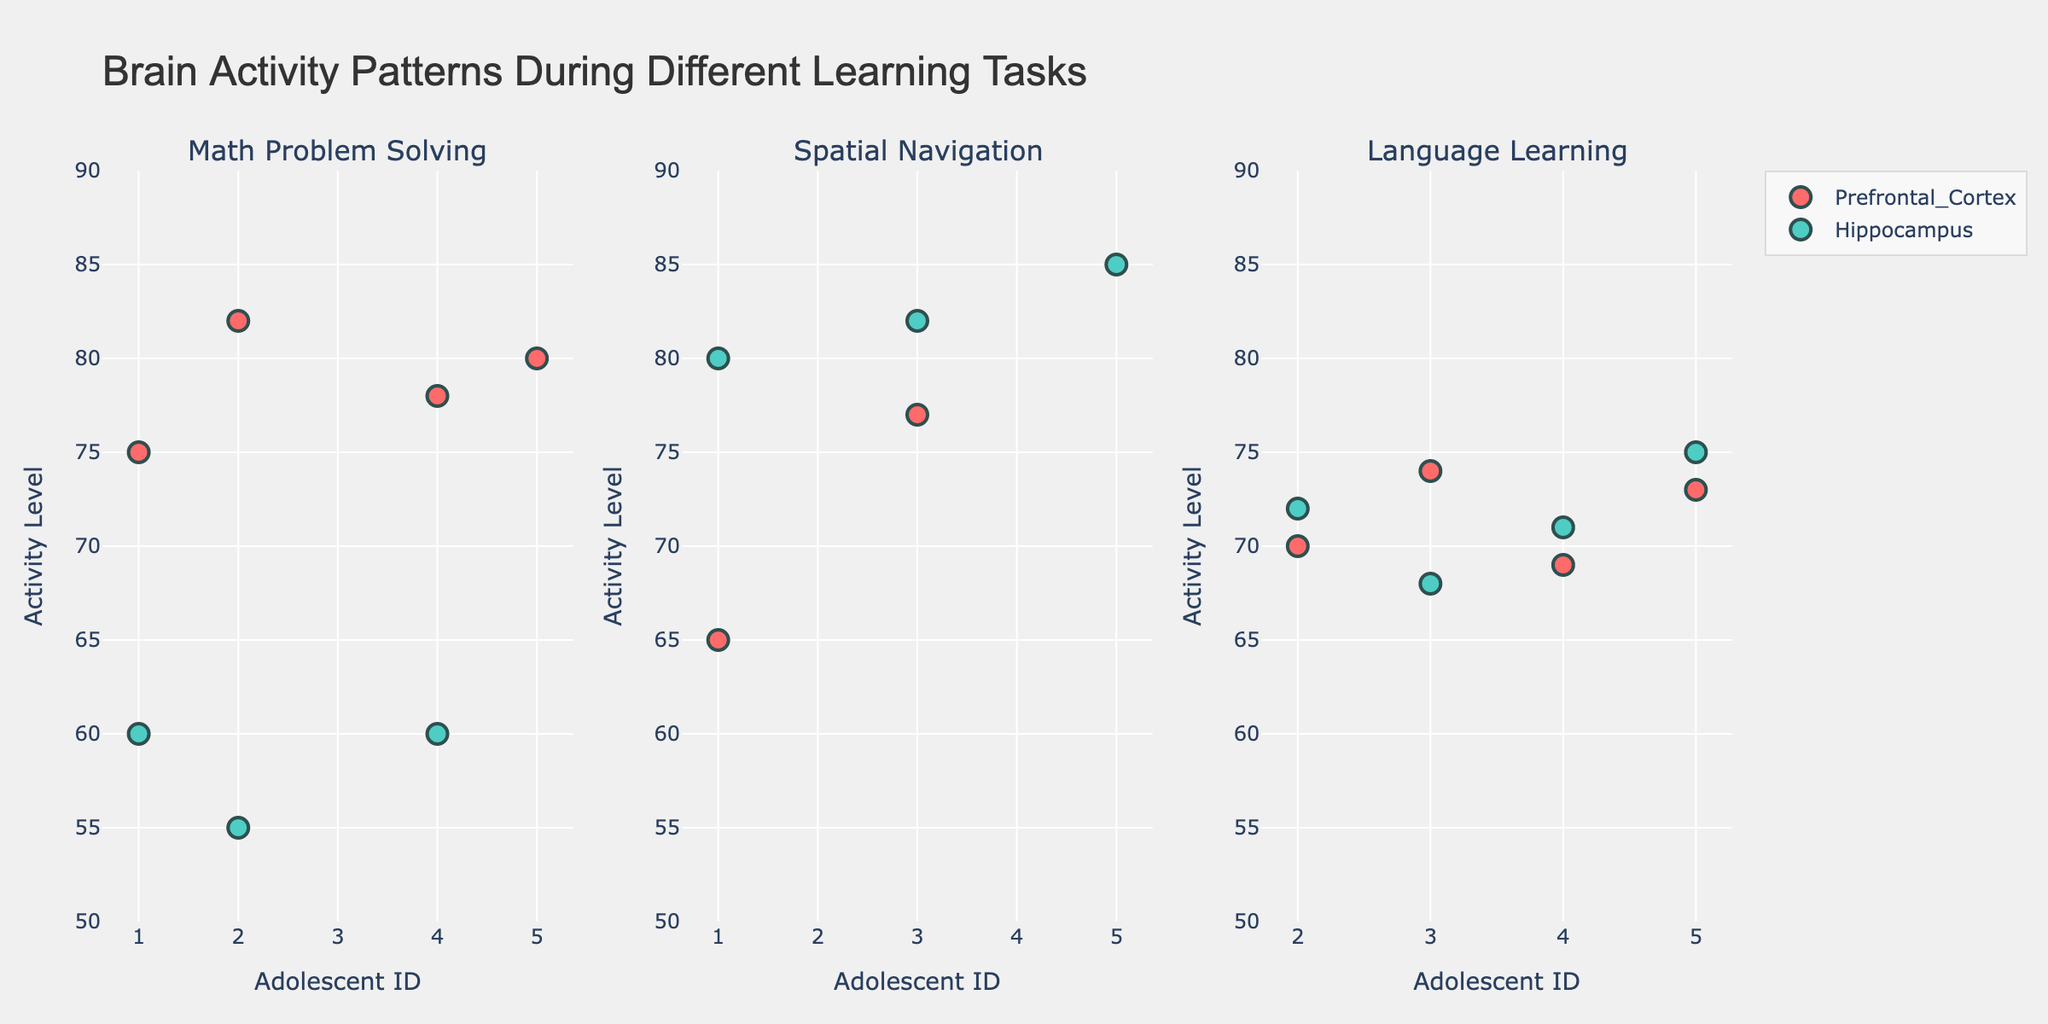What is the title of the figure? The title is usually found at the top of the figure and describes its overall subject. The title of this figure is given in the code update_layout call.
Answer: "Brain Activity Patterns During Different Learning Tasks" How many subplots are there in the figure? The make_subplots call in the code specifies 1 row and 3 columns, which means there are a total of 3 subplots.
Answer: 3 What color is used to represent the Prefrontal Cortex? The colors dictionary in the code indicates that the Prefrontal Cortex is represented in the color '#FF6B6B', which is a shade of red.
Answer: Red Which brain region shows higher activity levels during Spatial Navigation for Adolescent IDs 1 and 3? By examining the Spatial Navigation subplot, you can compare the markers for the Prefrontal Cortex and Hippocampus. For both Adolescent IDs 1 and 3, the markers for the Hippocampus are positioned higher on the y-axis than for the Prefrontal Cortex.
Answer: Hippocampus What is the range of activity levels shown on the y-axis? Checking the code's fig.update_yaxes call, the specified range for the Activity Level y-axis is from 50 to 90.
Answer: 50 to 90 Which Adolescent has the highest activity level in the Math Problem Solving task? Focus on the Math Problem Solving subplot and compare the y-values of the markers. Adolescent ID 2, with a Prefrontal Cortex activity level of 82, has the highest.
Answer: Adolescent ID 2 What is the difference in activity level for Adolescent ID 4 between the Math Problem Solving and Language Learning tasks in the Prefrontal Cortex? Adolescent ID 4 has an activity level of 78 in the Prefrontal Cortex during Math Problem Solving and 69 during Language Learning. The difference is 78 - 69 = 9.
Answer: 9 Which learning task shows the most consistent activity levels in the Hippocampus across all adolescents? The consistency can be determined by visually comparing the clustering of data points in the Hippocampus markers. By examining the subplots, the Language Learning task shows the tightest clustering of Hippocampus activity levels between 68 and 75.
Answer: Language Learning How many unique Adolescent IDs are represented in the plot? By examining the x-axis across all subplots, you will see that the Adolescent IDs range from 1 to 5, indicating 5 unique IDs.
Answer: 5 